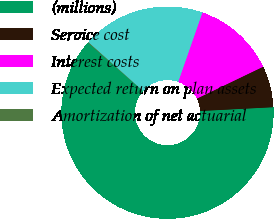<chart> <loc_0><loc_0><loc_500><loc_500><pie_chart><fcel>(millions)<fcel>Service cost<fcel>Interest costs<fcel>Expected return on plan assets<fcel>Amortization of net actuarial<nl><fcel>62.32%<fcel>6.31%<fcel>12.53%<fcel>18.76%<fcel>0.09%<nl></chart> 